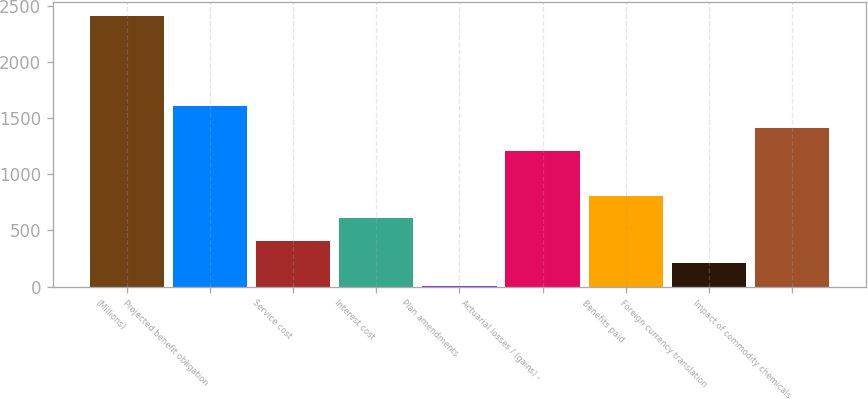<chart> <loc_0><loc_0><loc_500><loc_500><bar_chart><fcel>(Millions)<fcel>Projected benefit obligation<fcel>Service cost<fcel>Interest cost<fcel>Plan amendments<fcel>Actuarial losses / (gains) -<fcel>Benefits paid<fcel>Foreign currency translation<fcel>Impact of commodity chemicals<nl><fcel>2414<fcel>1612<fcel>409<fcel>609.5<fcel>8<fcel>1211<fcel>810<fcel>208.5<fcel>1411.5<nl></chart> 